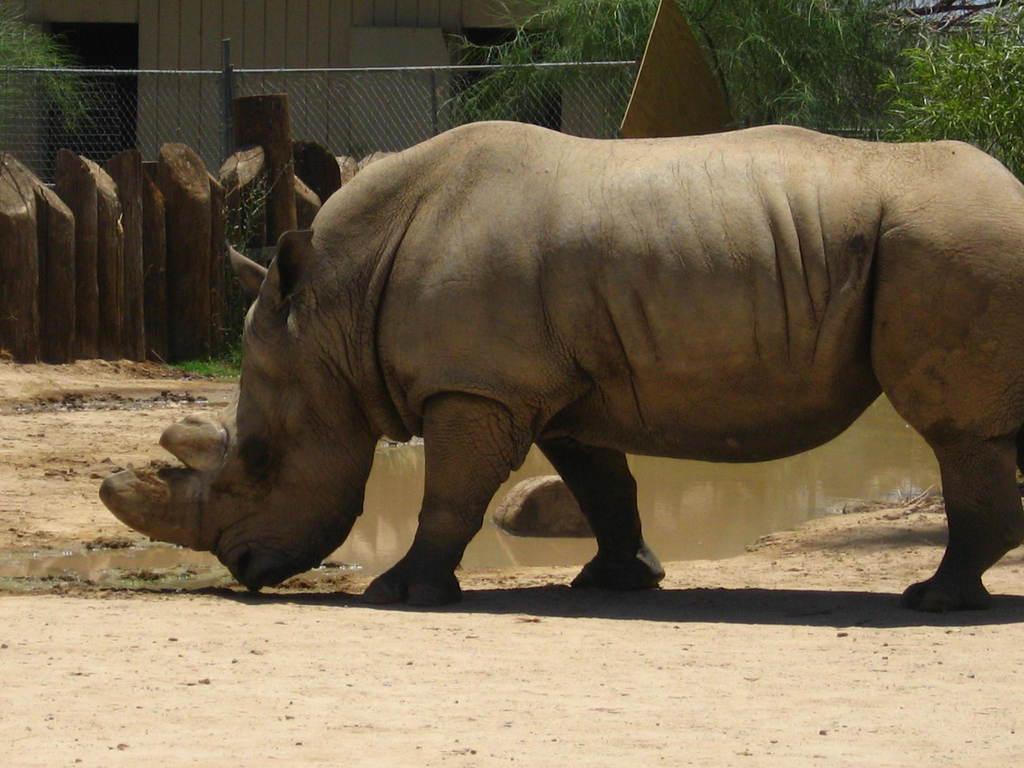Can you describe this image briefly? In this image I see a hippopotamus and I see the ground and I see the water over here. In the background I see the fencing and I see the leaves. 